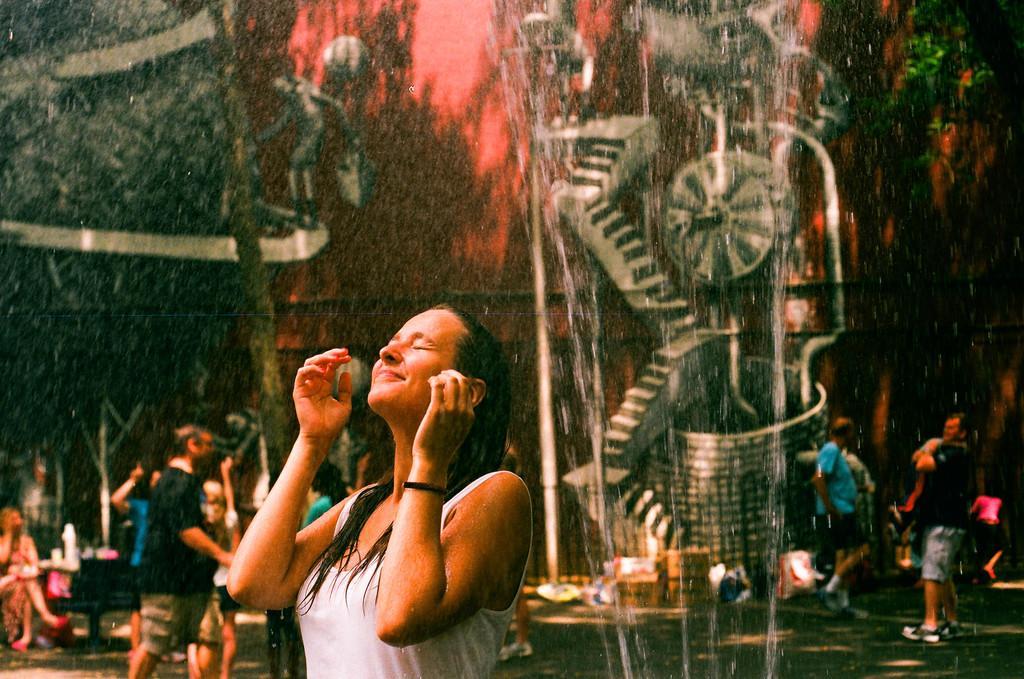Describe this image in one or two sentences. In the image we can see a woman wearing clothes and she is smiling. Around her there are many other people walking and some of them are standing and the background is blurred. We can even see it's raining. 